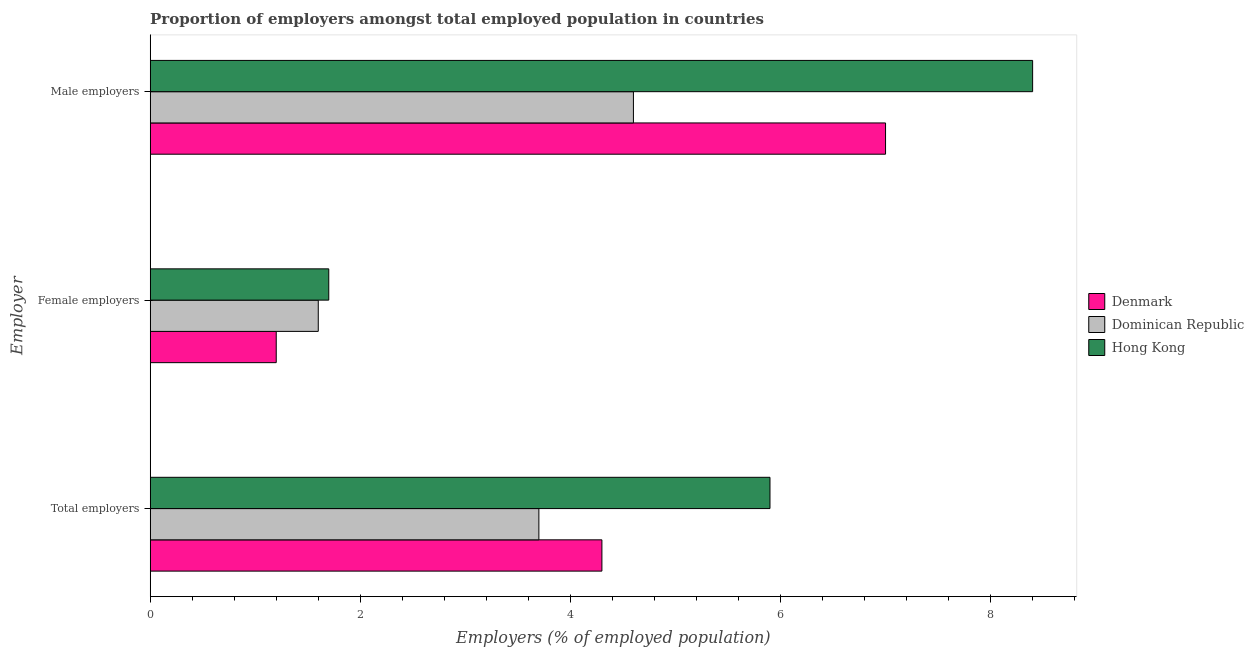How many different coloured bars are there?
Keep it short and to the point. 3. How many groups of bars are there?
Provide a short and direct response. 3. Are the number of bars on each tick of the Y-axis equal?
Make the answer very short. Yes. What is the label of the 3rd group of bars from the top?
Your response must be concise. Total employers. What is the percentage of male employers in Dominican Republic?
Your response must be concise. 4.6. Across all countries, what is the maximum percentage of female employers?
Your answer should be very brief. 1.7. Across all countries, what is the minimum percentage of total employers?
Keep it short and to the point. 3.7. In which country was the percentage of male employers maximum?
Your response must be concise. Hong Kong. What is the total percentage of female employers in the graph?
Make the answer very short. 4.5. What is the difference between the percentage of total employers in Hong Kong and that in Dominican Republic?
Offer a terse response. 2.2. What is the difference between the percentage of female employers in Dominican Republic and the percentage of total employers in Hong Kong?
Your answer should be very brief. -4.3. What is the average percentage of total employers per country?
Offer a terse response. 4.63. What is the difference between the percentage of female employers and percentage of male employers in Hong Kong?
Make the answer very short. -6.7. In how many countries, is the percentage of total employers greater than 5.6 %?
Keep it short and to the point. 1. What is the ratio of the percentage of total employers in Hong Kong to that in Denmark?
Ensure brevity in your answer.  1.37. Is the percentage of female employers in Denmark less than that in Hong Kong?
Make the answer very short. Yes. Is the difference between the percentage of total employers in Denmark and Hong Kong greater than the difference between the percentage of female employers in Denmark and Hong Kong?
Your answer should be compact. No. What is the difference between the highest and the second highest percentage of female employers?
Your answer should be very brief. 0.1. What is the difference between the highest and the lowest percentage of male employers?
Provide a short and direct response. 3.8. Is the sum of the percentage of total employers in Dominican Republic and Denmark greater than the maximum percentage of female employers across all countries?
Your answer should be compact. Yes. What does the 1st bar from the top in Female employers represents?
Your response must be concise. Hong Kong. What does the 2nd bar from the bottom in Male employers represents?
Your answer should be compact. Dominican Republic. Is it the case that in every country, the sum of the percentage of total employers and percentage of female employers is greater than the percentage of male employers?
Your answer should be compact. No. How many bars are there?
Keep it short and to the point. 9. Are all the bars in the graph horizontal?
Keep it short and to the point. Yes. How many countries are there in the graph?
Give a very brief answer. 3. Are the values on the major ticks of X-axis written in scientific E-notation?
Offer a terse response. No. Does the graph contain grids?
Your answer should be very brief. No. How are the legend labels stacked?
Keep it short and to the point. Vertical. What is the title of the graph?
Offer a terse response. Proportion of employers amongst total employed population in countries. What is the label or title of the X-axis?
Your response must be concise. Employers (% of employed population). What is the label or title of the Y-axis?
Provide a succinct answer. Employer. What is the Employers (% of employed population) in Denmark in Total employers?
Provide a short and direct response. 4.3. What is the Employers (% of employed population) of Dominican Republic in Total employers?
Offer a terse response. 3.7. What is the Employers (% of employed population) in Hong Kong in Total employers?
Offer a very short reply. 5.9. What is the Employers (% of employed population) of Denmark in Female employers?
Offer a very short reply. 1.2. What is the Employers (% of employed population) of Dominican Republic in Female employers?
Make the answer very short. 1.6. What is the Employers (% of employed population) in Hong Kong in Female employers?
Your answer should be very brief. 1.7. What is the Employers (% of employed population) of Dominican Republic in Male employers?
Give a very brief answer. 4.6. What is the Employers (% of employed population) in Hong Kong in Male employers?
Ensure brevity in your answer.  8.4. Across all Employer, what is the maximum Employers (% of employed population) in Dominican Republic?
Your answer should be compact. 4.6. Across all Employer, what is the maximum Employers (% of employed population) of Hong Kong?
Provide a succinct answer. 8.4. Across all Employer, what is the minimum Employers (% of employed population) of Denmark?
Offer a terse response. 1.2. Across all Employer, what is the minimum Employers (% of employed population) in Dominican Republic?
Your response must be concise. 1.6. Across all Employer, what is the minimum Employers (% of employed population) of Hong Kong?
Offer a very short reply. 1.7. What is the total Employers (% of employed population) in Dominican Republic in the graph?
Your answer should be very brief. 9.9. What is the total Employers (% of employed population) of Hong Kong in the graph?
Ensure brevity in your answer.  16. What is the difference between the Employers (% of employed population) in Dominican Republic in Total employers and that in Female employers?
Your answer should be compact. 2.1. What is the difference between the Employers (% of employed population) of Hong Kong in Total employers and that in Female employers?
Make the answer very short. 4.2. What is the difference between the Employers (% of employed population) of Denmark in Total employers and that in Male employers?
Provide a short and direct response. -2.7. What is the difference between the Employers (% of employed population) of Denmark in Female employers and that in Male employers?
Keep it short and to the point. -5.8. What is the difference between the Employers (% of employed population) of Dominican Republic in Female employers and that in Male employers?
Offer a terse response. -3. What is the difference between the Employers (% of employed population) in Hong Kong in Female employers and that in Male employers?
Your answer should be very brief. -6.7. What is the difference between the Employers (% of employed population) in Denmark in Total employers and the Employers (% of employed population) in Dominican Republic in Female employers?
Your response must be concise. 2.7. What is the difference between the Employers (% of employed population) of Denmark in Total employers and the Employers (% of employed population) of Hong Kong in Female employers?
Ensure brevity in your answer.  2.6. What is the difference between the Employers (% of employed population) of Denmark in Total employers and the Employers (% of employed population) of Dominican Republic in Male employers?
Your answer should be very brief. -0.3. What is the difference between the Employers (% of employed population) in Denmark in Total employers and the Employers (% of employed population) in Hong Kong in Male employers?
Your response must be concise. -4.1. What is the difference between the Employers (% of employed population) of Denmark in Female employers and the Employers (% of employed population) of Dominican Republic in Male employers?
Give a very brief answer. -3.4. What is the average Employers (% of employed population) in Denmark per Employer?
Ensure brevity in your answer.  4.17. What is the average Employers (% of employed population) in Hong Kong per Employer?
Ensure brevity in your answer.  5.33. What is the difference between the Employers (% of employed population) in Denmark and Employers (% of employed population) in Dominican Republic in Total employers?
Make the answer very short. 0.6. What is the difference between the Employers (% of employed population) in Denmark and Employers (% of employed population) in Hong Kong in Total employers?
Your response must be concise. -1.6. What is the difference between the Employers (% of employed population) in Denmark and Employers (% of employed population) in Dominican Republic in Male employers?
Ensure brevity in your answer.  2.4. What is the difference between the Employers (% of employed population) in Denmark and Employers (% of employed population) in Hong Kong in Male employers?
Keep it short and to the point. -1.4. What is the ratio of the Employers (% of employed population) of Denmark in Total employers to that in Female employers?
Make the answer very short. 3.58. What is the ratio of the Employers (% of employed population) of Dominican Republic in Total employers to that in Female employers?
Make the answer very short. 2.31. What is the ratio of the Employers (% of employed population) of Hong Kong in Total employers to that in Female employers?
Offer a terse response. 3.47. What is the ratio of the Employers (% of employed population) of Denmark in Total employers to that in Male employers?
Provide a short and direct response. 0.61. What is the ratio of the Employers (% of employed population) in Dominican Republic in Total employers to that in Male employers?
Provide a short and direct response. 0.8. What is the ratio of the Employers (% of employed population) in Hong Kong in Total employers to that in Male employers?
Keep it short and to the point. 0.7. What is the ratio of the Employers (% of employed population) in Denmark in Female employers to that in Male employers?
Your answer should be compact. 0.17. What is the ratio of the Employers (% of employed population) of Dominican Republic in Female employers to that in Male employers?
Your answer should be compact. 0.35. What is the ratio of the Employers (% of employed population) in Hong Kong in Female employers to that in Male employers?
Offer a very short reply. 0.2. What is the difference between the highest and the second highest Employers (% of employed population) of Dominican Republic?
Make the answer very short. 0.9. What is the difference between the highest and the lowest Employers (% of employed population) of Denmark?
Offer a very short reply. 5.8. What is the difference between the highest and the lowest Employers (% of employed population) in Dominican Republic?
Your answer should be compact. 3. 